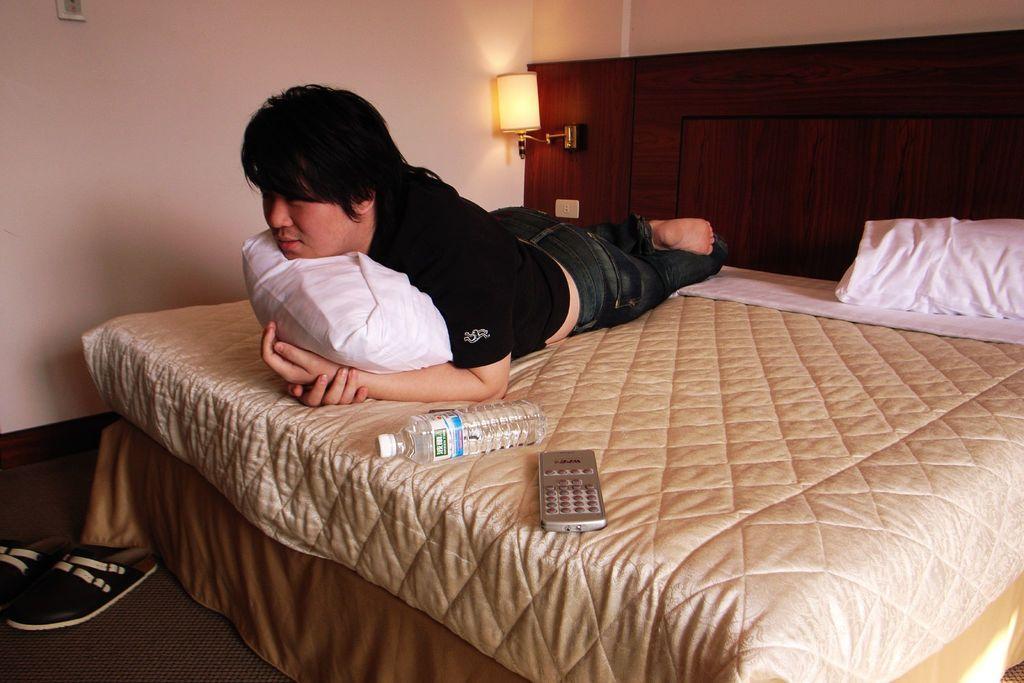How would you summarize this image in a sentence or two? In the middle of the image a man is laying on the bed. Beside him there is a water bottle and remote. At the top of the image there is a wall and light. Bottom left side of the image there are some chappal. 